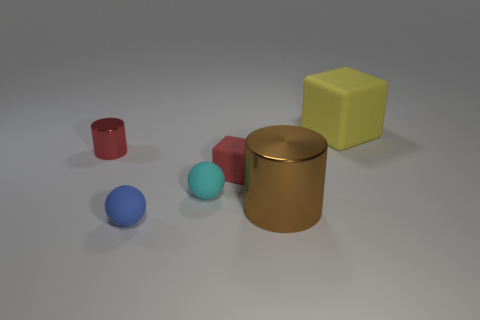Add 2 brown things. How many objects exist? 8 Subtract all balls. How many objects are left? 4 Add 4 metallic things. How many metallic things exist? 6 Subtract 0 cyan cubes. How many objects are left? 6 Subtract all large brown objects. Subtract all red shiny things. How many objects are left? 4 Add 2 small red rubber blocks. How many small red rubber blocks are left? 3 